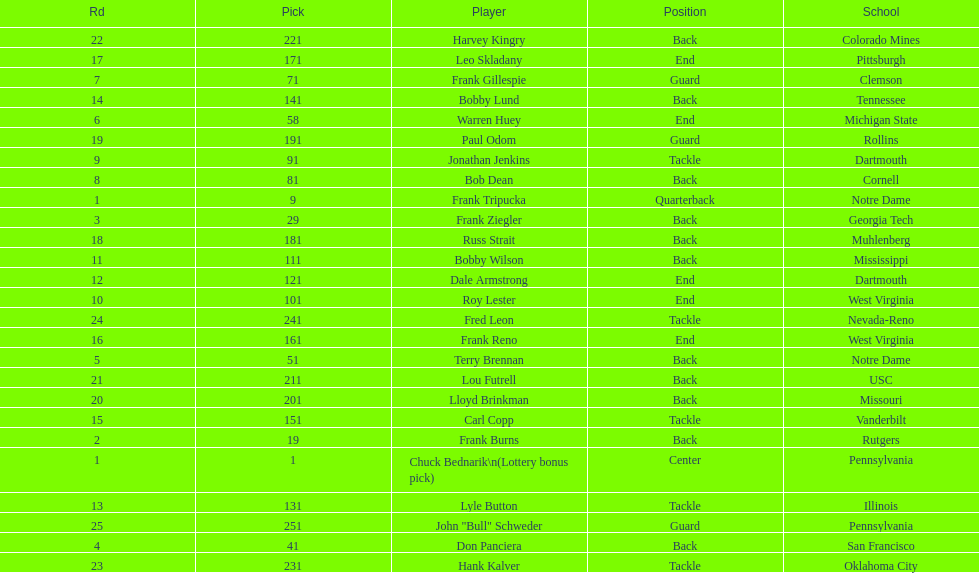Highest rd number? 25. 